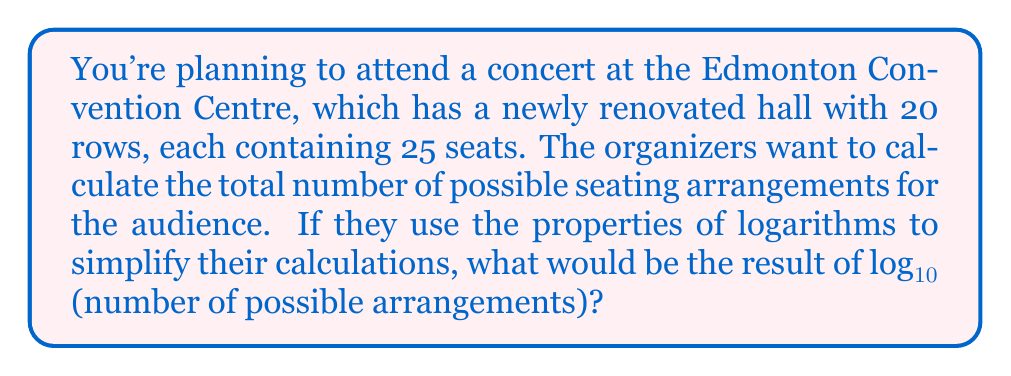Show me your answer to this math problem. Let's approach this step-by-step:

1) First, we need to calculate the total number of seats:
   $20 \text{ rows} \times 25 \text{ seats per row} = 500 \text{ seats}$

2) The number of possible seating arrangements is equal to the number of permutations of 500 people, which is 500!

3) We need to find $\log_{10}(500!)$

4) Using the logarithm property $\log(ab) = \log(a) + \log(b)$, we can expand this to:

   $\log_{10}(500!) = \log_{10}(1) + \log_{10}(2) + \log_{10}(3) + ... + \log_{10}(499) + \log_{10}(500)$

5) This sum can be approximated using Stirling's approximation:

   $\log_{10}(n!) \approx n\log_{10}(n) - n\log_{10}(e) + \frac{1}{2}\log_{10}(2\pi n)$

6) Plugging in $n = 500$:

   $\log_{10}(500!) \approx 500\log_{10}(500) - 500\log_{10}(e) + \frac{1}{2}\log_{10}(2\pi 500)$

7) Calculating:
   
   $500\log_{10}(500) \approx 1349.4857$
   $500\log_{10}(e) \approx 217.1472$
   $\frac{1}{2}\log_{10}(2\pi 500) \approx 1.5511$

8) Summing these up:

   $1349.4857 - 217.1472 + 1.5511 \approx 1133.8896$
Answer: $\log_{10}$ of the number of possible seating arrangements is approximately 1133.8896. 